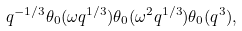<formula> <loc_0><loc_0><loc_500><loc_500>q ^ { - 1 / 3 } \theta _ { 0 } ( \omega q ^ { 1 / 3 } ) \theta _ { 0 } ( \omega ^ { 2 } q ^ { 1 / 3 } ) \theta _ { 0 } ( q ^ { 3 } ) ,</formula> 